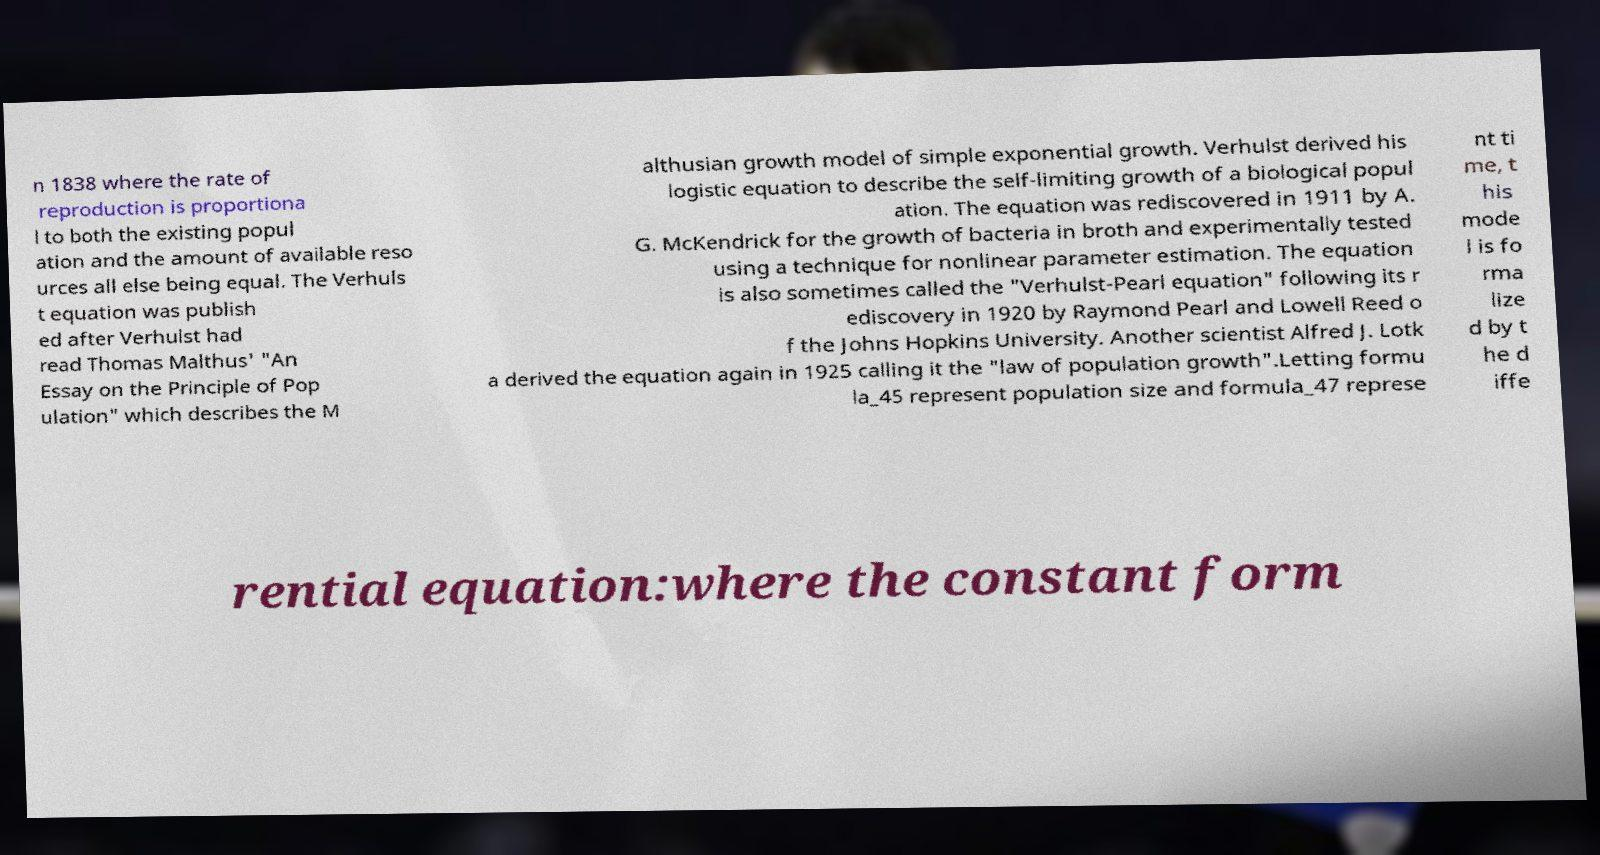Please identify and transcribe the text found in this image. n 1838 where the rate of reproduction is proportiona l to both the existing popul ation and the amount of available reso urces all else being equal. The Verhuls t equation was publish ed after Verhulst had read Thomas Malthus' "An Essay on the Principle of Pop ulation" which describes the M althusian growth model of simple exponential growth. Verhulst derived his logistic equation to describe the self-limiting growth of a biological popul ation. The equation was rediscovered in 1911 by A. G. McKendrick for the growth of bacteria in broth and experimentally tested using a technique for nonlinear parameter estimation. The equation is also sometimes called the "Verhulst-Pearl equation" following its r ediscovery in 1920 by Raymond Pearl and Lowell Reed o f the Johns Hopkins University. Another scientist Alfred J. Lotk a derived the equation again in 1925 calling it the "law of population growth".Letting formu la_45 represent population size and formula_47 represe nt ti me, t his mode l is fo rma lize d by t he d iffe rential equation:where the constant form 